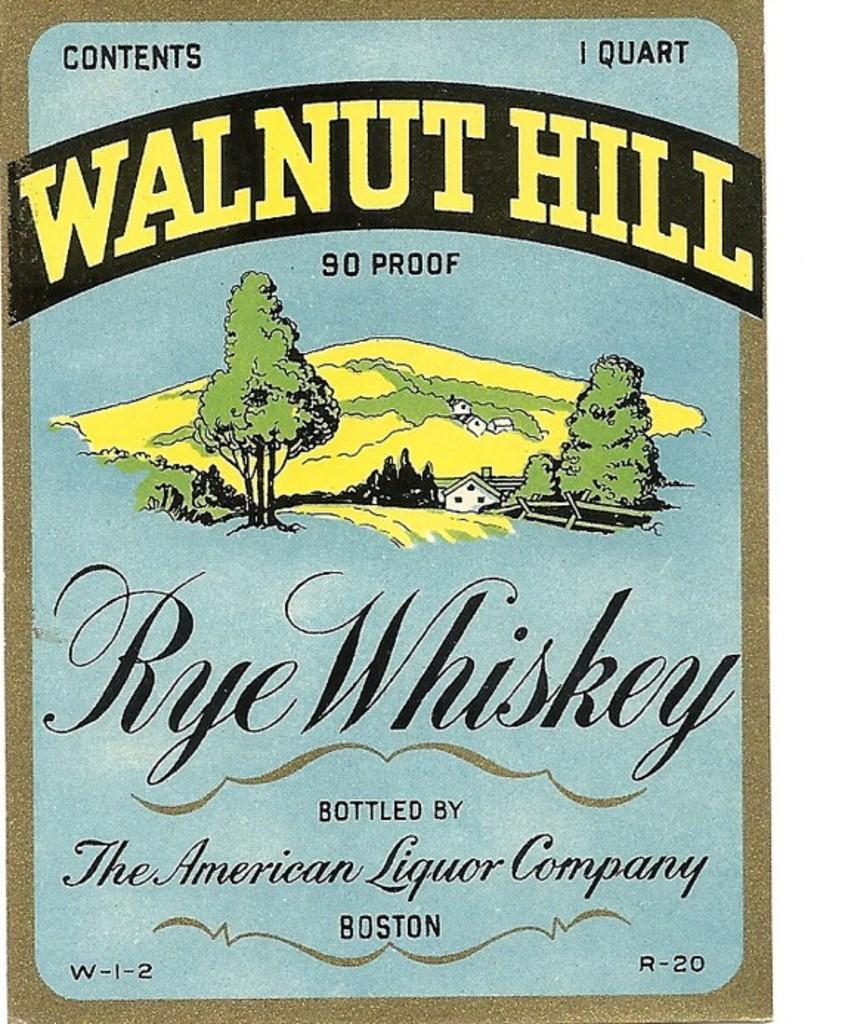Describe this image in one or two sentences. In this image I see a poster on which there is something written and I see the depiction of trees and a house over here. 